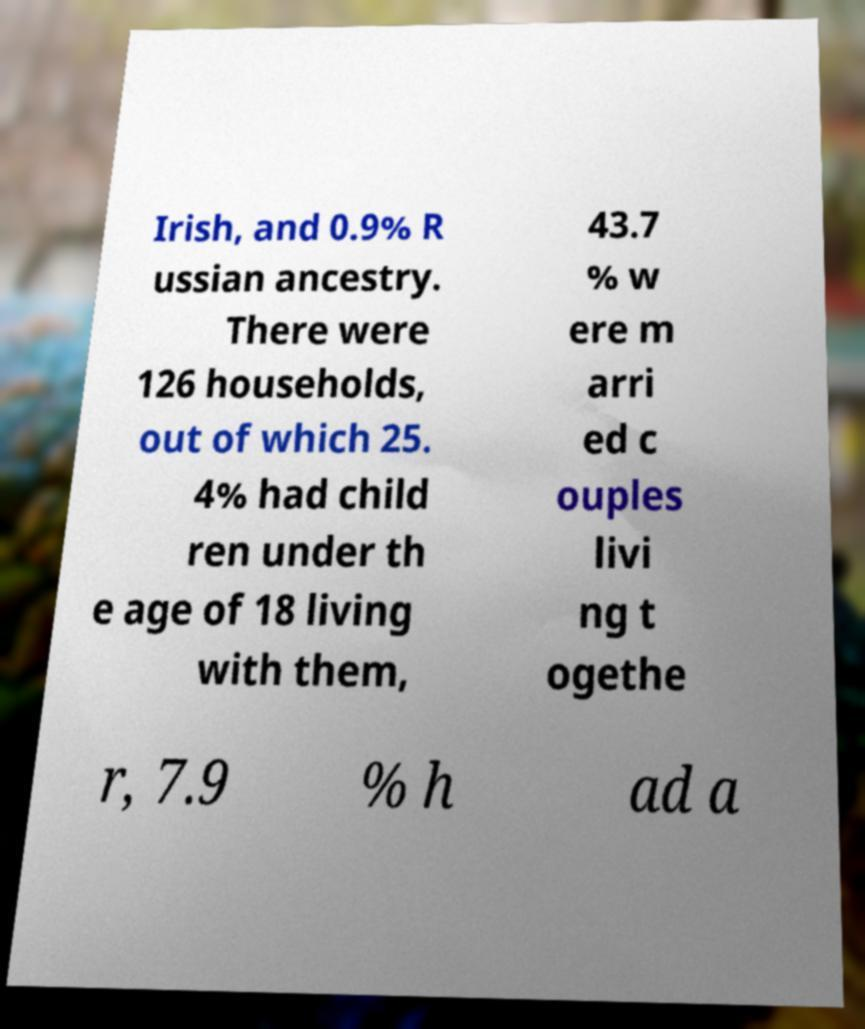Can you accurately transcribe the text from the provided image for me? Irish, and 0.9% R ussian ancestry. There were 126 households, out of which 25. 4% had child ren under th e age of 18 living with them, 43.7 % w ere m arri ed c ouples livi ng t ogethe r, 7.9 % h ad a 